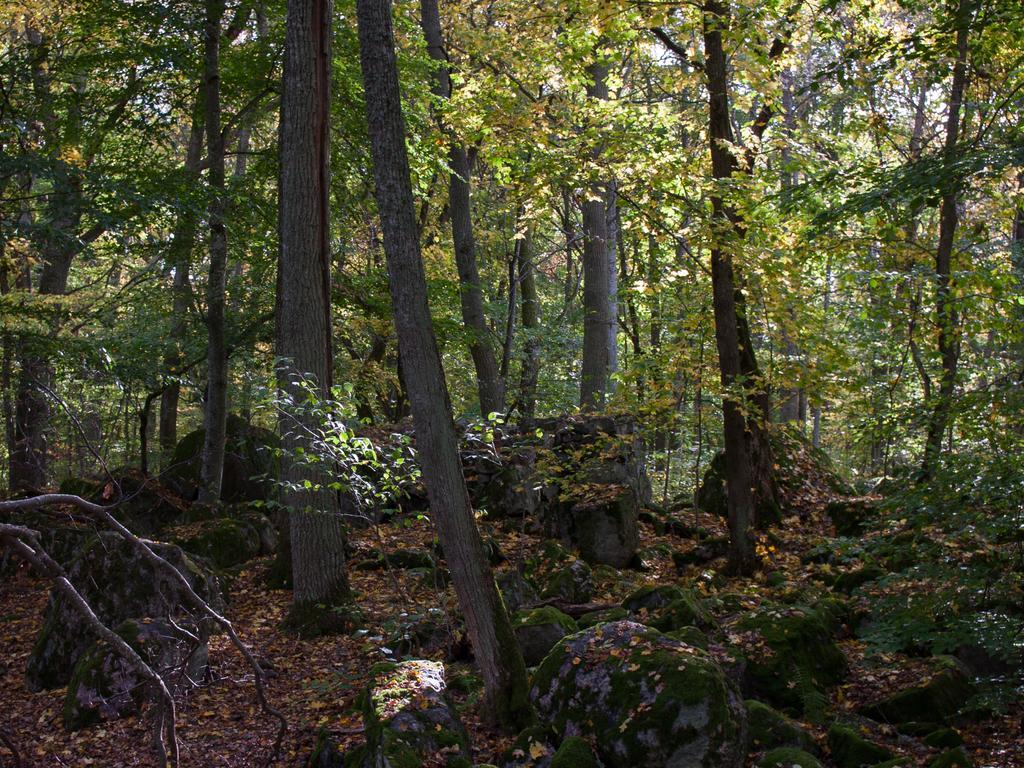How would you summarize this image in a sentence or two? In this image we can see trees, rocks, and dried leaves. 